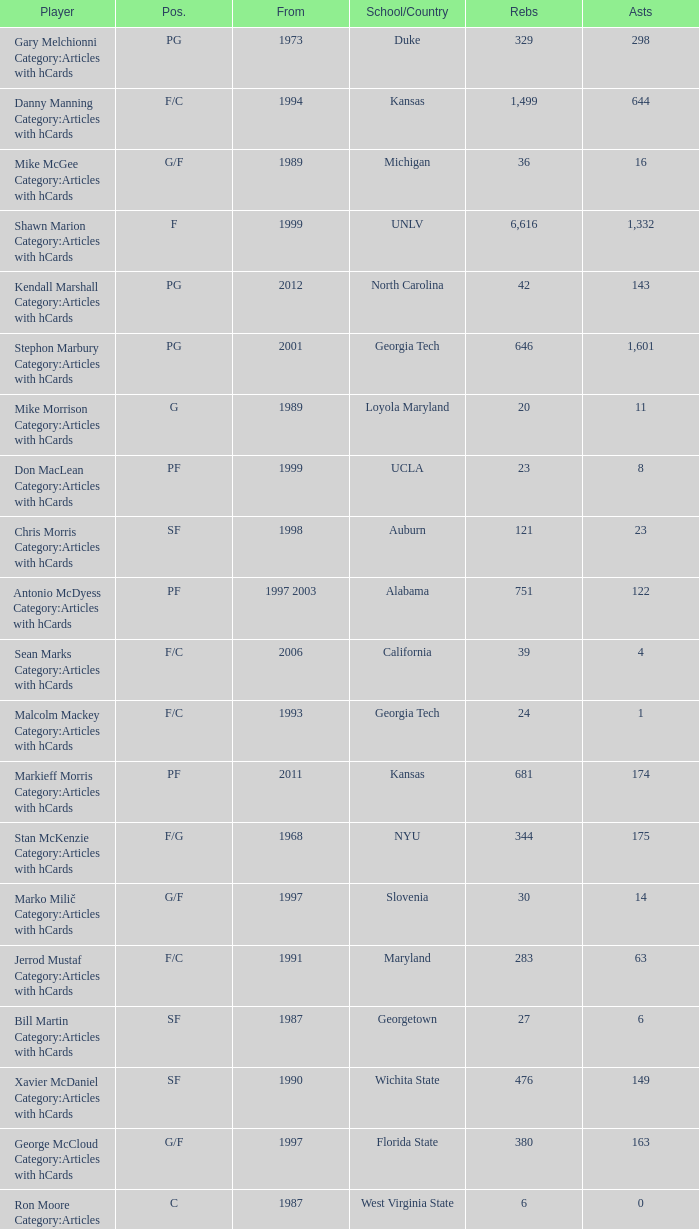What position does the player from arkansas play? C. 